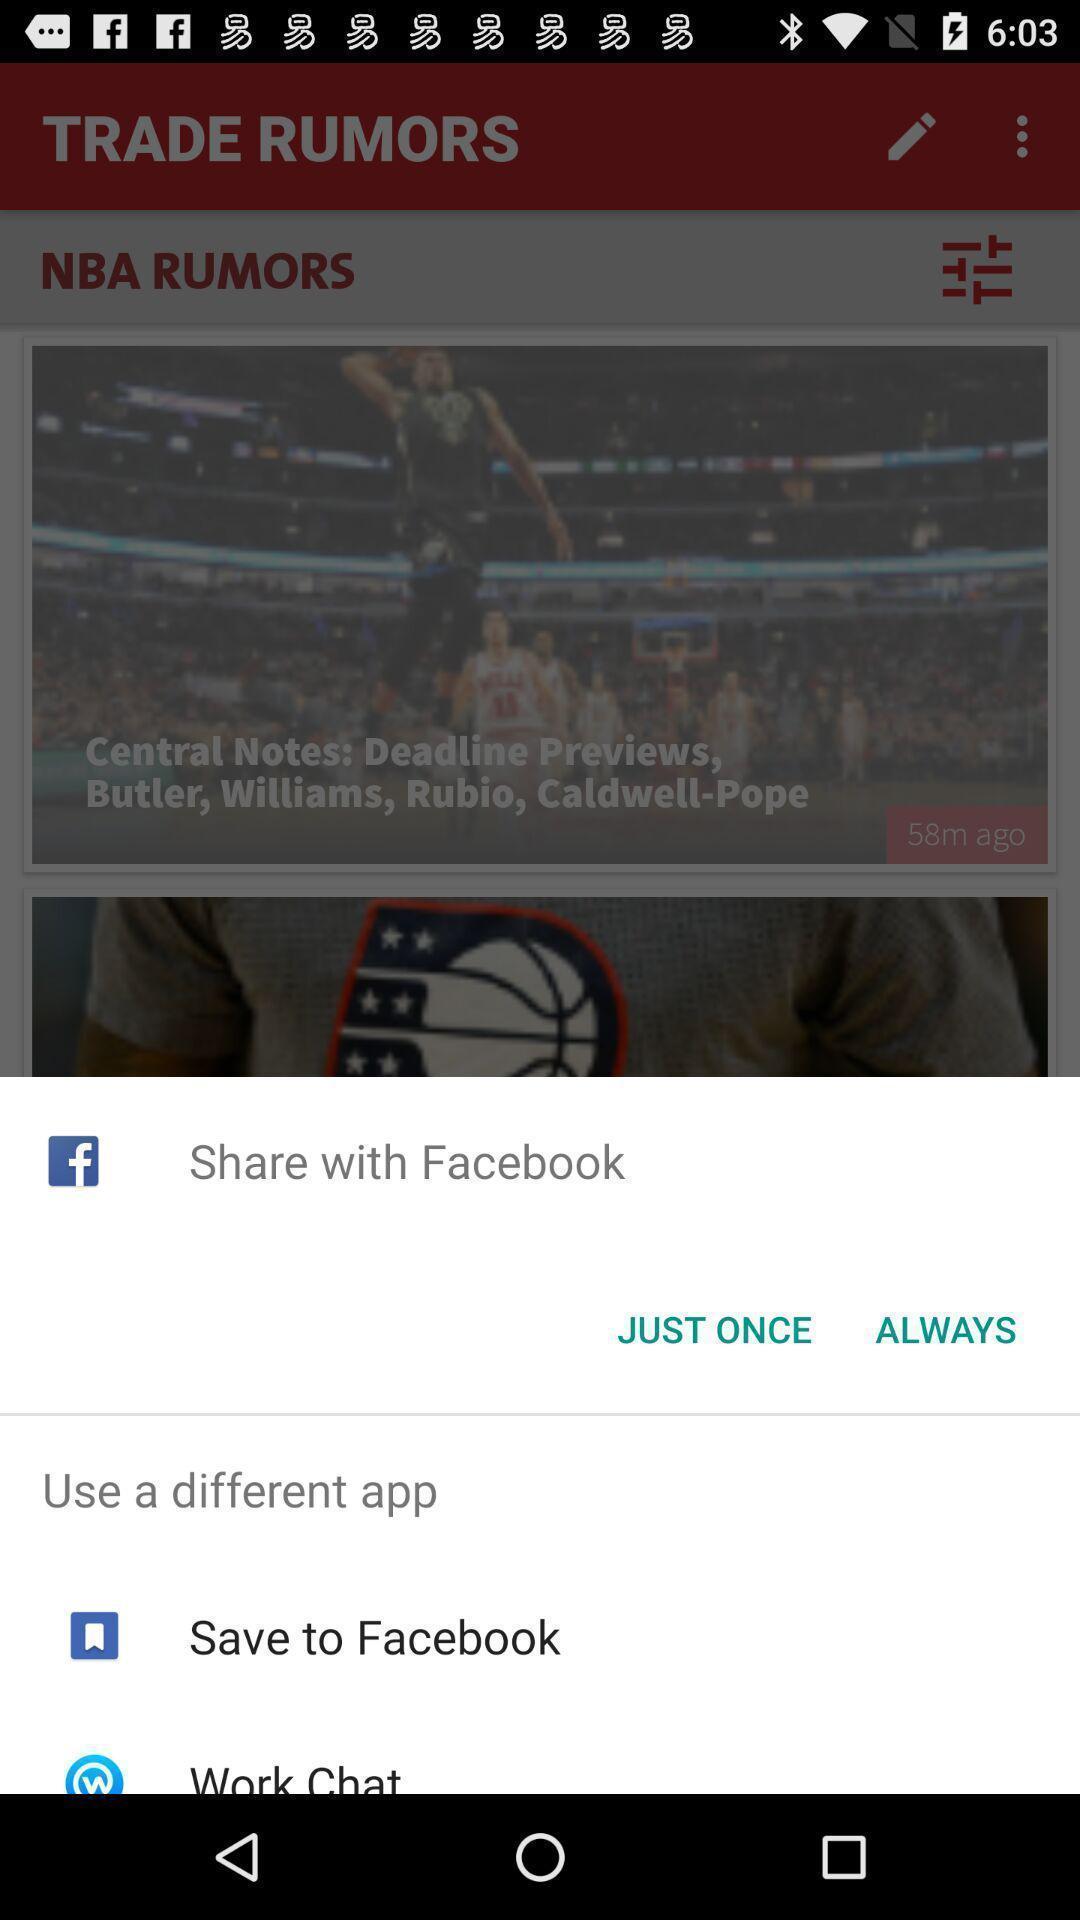Give me a narrative description of this picture. Pop-up displaying various sharing options. 